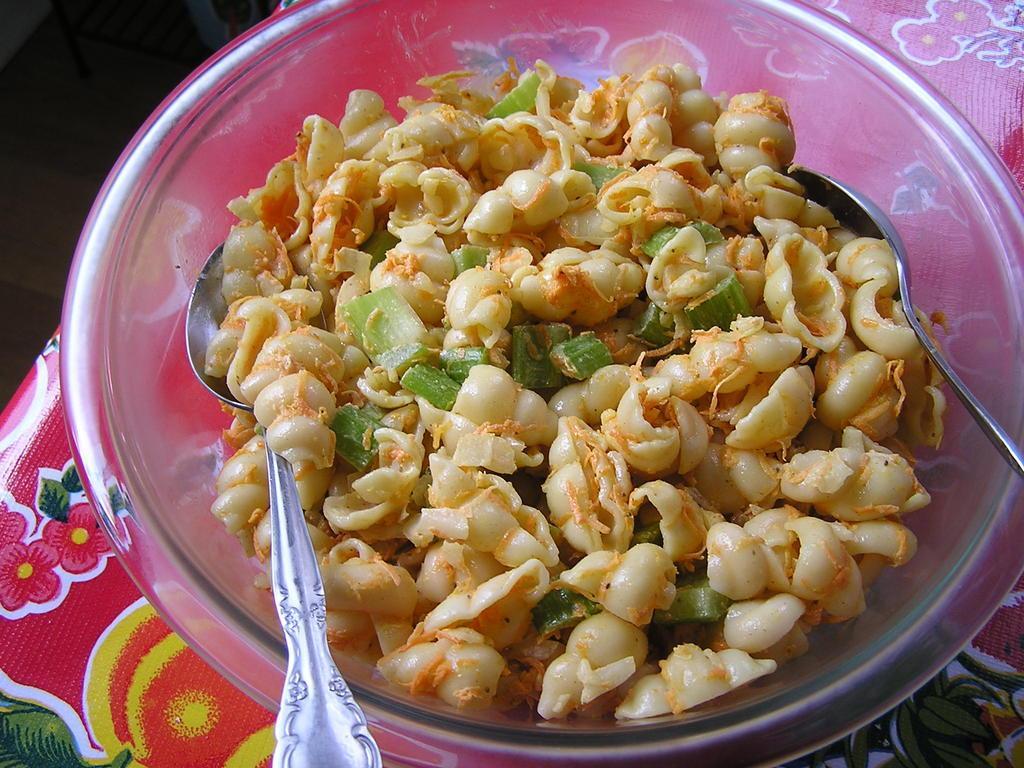Please provide a concise description of this image. In this image I can see a red and yellow colored surface and on it I can see a glass bowl. In the bowl I can see a food item which is cream and green in color. I can see two spoons in the bowl. 